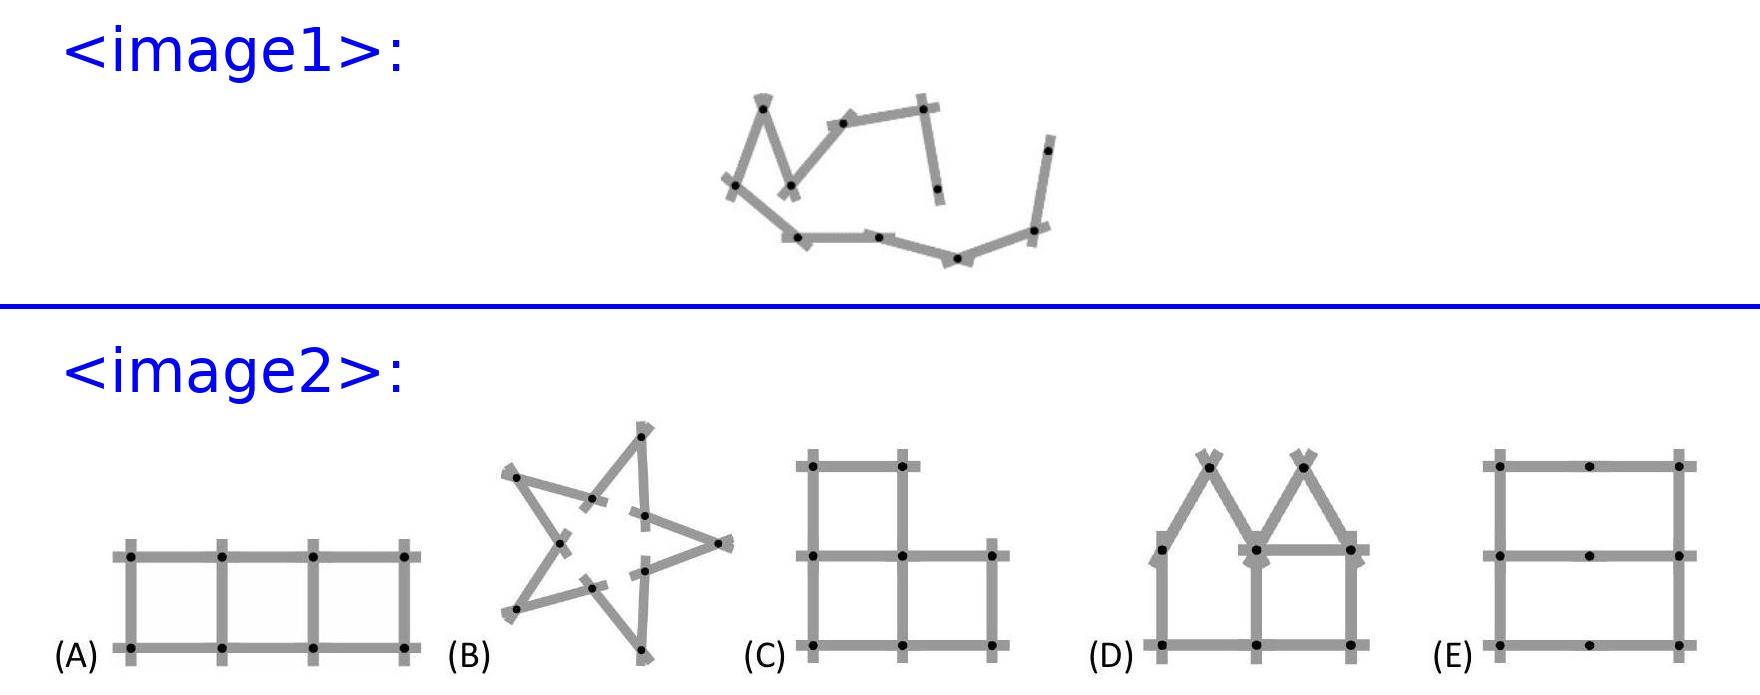<image2> What are the specific characteristics of figure C that differentiate it from the other figures? Figure C is unique as it forms a perfect five-pointed star with equal angles and distances between each point. This symmetry is in contrast to the other figures, which either form structures with right angles or more complex shapes like the house in figure E. 